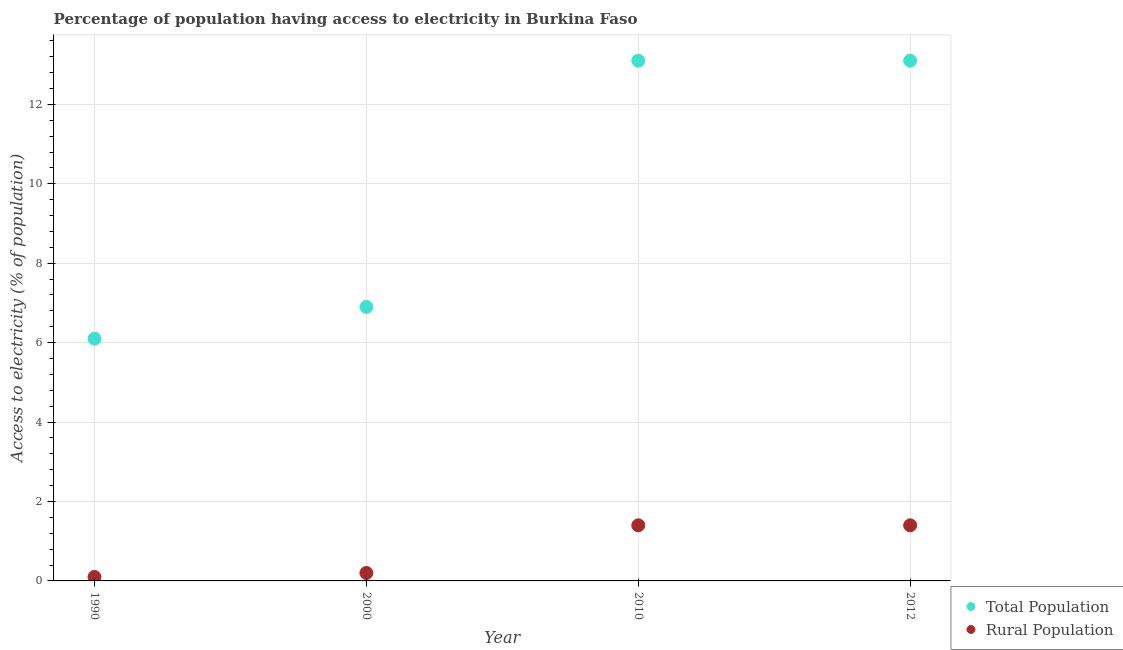Is the number of dotlines equal to the number of legend labels?
Your response must be concise. Yes. What is the percentage of rural population having access to electricity in 1990?
Offer a terse response. 0.1. Across all years, what is the minimum percentage of population having access to electricity?
Ensure brevity in your answer.  6.1. What is the total percentage of rural population having access to electricity in the graph?
Your answer should be compact. 3.1. What is the difference between the percentage of rural population having access to electricity in 2010 and that in 2012?
Your answer should be compact. 0. What is the difference between the percentage of rural population having access to electricity in 2010 and the percentage of population having access to electricity in 1990?
Ensure brevity in your answer.  -4.7. What is the average percentage of rural population having access to electricity per year?
Provide a succinct answer. 0.77. In how many years, is the percentage of rural population having access to electricity greater than 10 %?
Your answer should be very brief. 0. What is the ratio of the percentage of rural population having access to electricity in 2000 to that in 2010?
Offer a terse response. 0.14. Is the difference between the percentage of population having access to electricity in 2000 and 2012 greater than the difference between the percentage of rural population having access to electricity in 2000 and 2012?
Give a very brief answer. No. What is the difference between the highest and the second highest percentage of population having access to electricity?
Give a very brief answer. 0. What is the difference between the highest and the lowest percentage of rural population having access to electricity?
Your answer should be very brief. 1.3. Is the sum of the percentage of rural population having access to electricity in 1990 and 2010 greater than the maximum percentage of population having access to electricity across all years?
Give a very brief answer. No. Does the percentage of rural population having access to electricity monotonically increase over the years?
Your response must be concise. No. Is the percentage of rural population having access to electricity strictly greater than the percentage of population having access to electricity over the years?
Your answer should be compact. No. Is the percentage of population having access to electricity strictly less than the percentage of rural population having access to electricity over the years?
Provide a short and direct response. No. What is the difference between two consecutive major ticks on the Y-axis?
Offer a very short reply. 2. Does the graph contain any zero values?
Provide a short and direct response. No. Does the graph contain grids?
Offer a very short reply. Yes. Where does the legend appear in the graph?
Your answer should be very brief. Bottom right. How many legend labels are there?
Provide a succinct answer. 2. How are the legend labels stacked?
Keep it short and to the point. Vertical. What is the title of the graph?
Your answer should be very brief. Percentage of population having access to electricity in Burkina Faso. Does "Nitrous oxide emissions" appear as one of the legend labels in the graph?
Give a very brief answer. No. What is the label or title of the Y-axis?
Your response must be concise. Access to electricity (% of population). What is the Access to electricity (% of population) in Total Population in 2000?
Offer a terse response. 6.9. What is the Access to electricity (% of population) of Total Population in 2012?
Your answer should be compact. 13.1. Across all years, what is the maximum Access to electricity (% of population) of Rural Population?
Provide a short and direct response. 1.4. Across all years, what is the minimum Access to electricity (% of population) in Total Population?
Make the answer very short. 6.1. What is the total Access to electricity (% of population) in Total Population in the graph?
Offer a very short reply. 39.2. What is the difference between the Access to electricity (% of population) in Total Population in 1990 and that in 2000?
Offer a terse response. -0.8. What is the difference between the Access to electricity (% of population) in Total Population in 1990 and that in 2010?
Make the answer very short. -7. What is the difference between the Access to electricity (% of population) of Rural Population in 1990 and that in 2010?
Your answer should be compact. -1.3. What is the difference between the Access to electricity (% of population) of Total Population in 2000 and that in 2010?
Your answer should be compact. -6.2. What is the difference between the Access to electricity (% of population) in Rural Population in 2000 and that in 2010?
Provide a succinct answer. -1.2. What is the difference between the Access to electricity (% of population) in Total Population in 2000 and that in 2012?
Your answer should be very brief. -6.2. What is the difference between the Access to electricity (% of population) in Rural Population in 2000 and that in 2012?
Make the answer very short. -1.2. What is the difference between the Access to electricity (% of population) in Total Population in 1990 and the Access to electricity (% of population) in Rural Population in 2000?
Give a very brief answer. 5.9. What is the difference between the Access to electricity (% of population) of Total Population in 1990 and the Access to electricity (% of population) of Rural Population in 2010?
Keep it short and to the point. 4.7. What is the difference between the Access to electricity (% of population) in Total Population in 2010 and the Access to electricity (% of population) in Rural Population in 2012?
Give a very brief answer. 11.7. What is the average Access to electricity (% of population) in Rural Population per year?
Make the answer very short. 0.78. In the year 1990, what is the difference between the Access to electricity (% of population) in Total Population and Access to electricity (% of population) in Rural Population?
Offer a terse response. 6. In the year 2000, what is the difference between the Access to electricity (% of population) of Total Population and Access to electricity (% of population) of Rural Population?
Your answer should be compact. 6.7. In the year 2010, what is the difference between the Access to electricity (% of population) of Total Population and Access to electricity (% of population) of Rural Population?
Your answer should be compact. 11.7. In the year 2012, what is the difference between the Access to electricity (% of population) in Total Population and Access to electricity (% of population) in Rural Population?
Ensure brevity in your answer.  11.7. What is the ratio of the Access to electricity (% of population) in Total Population in 1990 to that in 2000?
Your answer should be compact. 0.88. What is the ratio of the Access to electricity (% of population) in Rural Population in 1990 to that in 2000?
Ensure brevity in your answer.  0.5. What is the ratio of the Access to electricity (% of population) in Total Population in 1990 to that in 2010?
Offer a terse response. 0.47. What is the ratio of the Access to electricity (% of population) of Rural Population in 1990 to that in 2010?
Make the answer very short. 0.07. What is the ratio of the Access to electricity (% of population) of Total Population in 1990 to that in 2012?
Your response must be concise. 0.47. What is the ratio of the Access to electricity (% of population) of Rural Population in 1990 to that in 2012?
Provide a short and direct response. 0.07. What is the ratio of the Access to electricity (% of population) of Total Population in 2000 to that in 2010?
Make the answer very short. 0.53. What is the ratio of the Access to electricity (% of population) of Rural Population in 2000 to that in 2010?
Give a very brief answer. 0.14. What is the ratio of the Access to electricity (% of population) of Total Population in 2000 to that in 2012?
Make the answer very short. 0.53. What is the ratio of the Access to electricity (% of population) in Rural Population in 2000 to that in 2012?
Your response must be concise. 0.14. What is the ratio of the Access to electricity (% of population) of Total Population in 2010 to that in 2012?
Provide a short and direct response. 1. What is the difference between the highest and the lowest Access to electricity (% of population) in Total Population?
Provide a succinct answer. 7. 